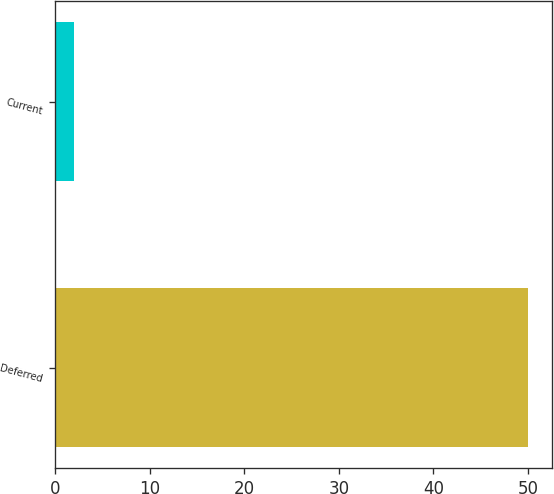Convert chart. <chart><loc_0><loc_0><loc_500><loc_500><bar_chart><fcel>Deferred<fcel>Current<nl><fcel>50<fcel>2<nl></chart> 